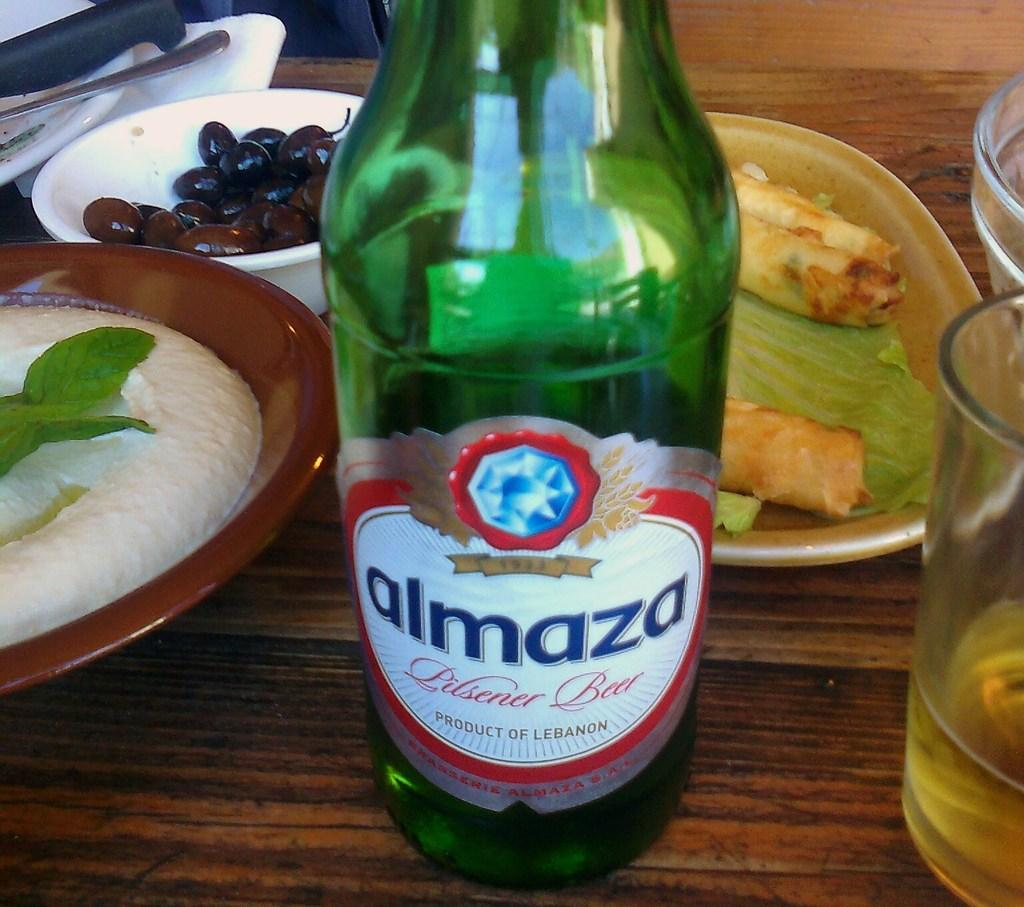<image>
Write a terse but informative summary of the picture. A green bottle of Almaza sits on a table. 